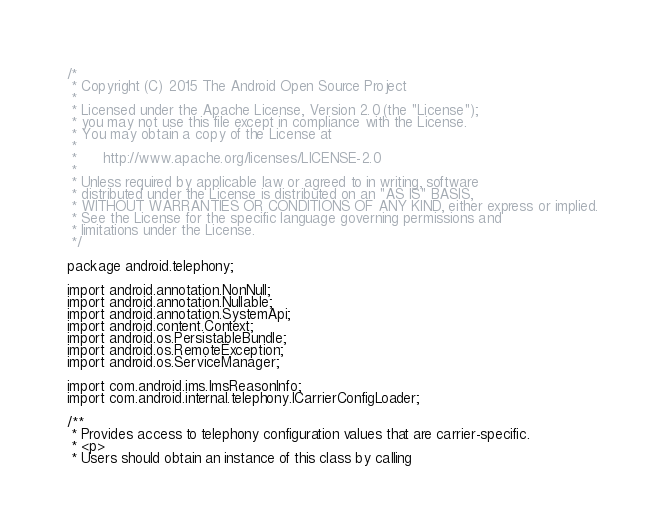<code> <loc_0><loc_0><loc_500><loc_500><_Java_>/*
 * Copyright (C) 2015 The Android Open Source Project
 *
 * Licensed under the Apache License, Version 2.0 (the "License");
 * you may not use this file except in compliance with the License.
 * You may obtain a copy of the License at
 *
 *      http://www.apache.org/licenses/LICENSE-2.0
 *
 * Unless required by applicable law or agreed to in writing, software
 * distributed under the License is distributed on an "AS IS" BASIS,
 * WITHOUT WARRANTIES OR CONDITIONS OF ANY KIND, either express or implied.
 * See the License for the specific language governing permissions and
 * limitations under the License.
 */

package android.telephony;

import android.annotation.NonNull;
import android.annotation.Nullable;
import android.annotation.SystemApi;
import android.content.Context;
import android.os.PersistableBundle;
import android.os.RemoteException;
import android.os.ServiceManager;

import com.android.ims.ImsReasonInfo;
import com.android.internal.telephony.ICarrierConfigLoader;

/**
 * Provides access to telephony configuration values that are carrier-specific.
 * <p>
 * Users should obtain an instance of this class by calling</code> 